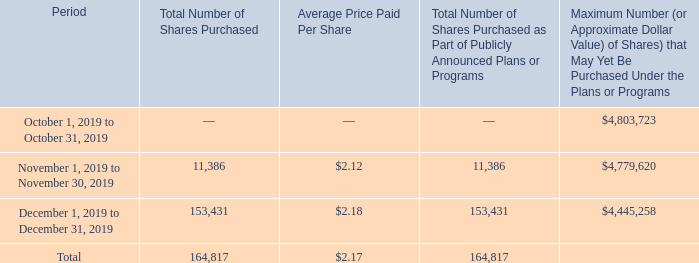Stock Repurchases. On August 22, 2011, we established a share repurchase program ("Share Repurchase Program"). On June 11, 2019, our Board of Directors authorized an extension and increase of the Share Repurchase Program to repurchase up to $5,000,000 of shares of our common stock over the subsequent 24 month period (for a total authorization of approximately $22,000,000 since inception of the program in August 2011). The common stock may be repurchased from time to time in open market transactions or privately negotiated transactions in our discretion. The timing and amount of the shares repurchased is determined by management based on its evaluation of market conditions and other factors. The Share Repurchase Program may be increased, suspended or discontinued at any time.
During the months of October, November and December 2019, we repurchased common stock pursuant to our Share Repurchase Program as indicated below:
During the year ended December 31, 2019, we repurchased an aggregate of 335,372 shares of our common stock pursuant to our Share Repurchase Program at a cost of approximately $764,606 (exclusive of commissions) or an average price per share of $2.28.
During the year ended December 31, 2019, we repurchased an aggregate of 335,372 shares of our common stock pursuant to our Share Repurchase Program at a cost of approximately $764,606 (exclusive of commissions) or an average price per share of $2.28.
Since inception of our Share Repurchase Program (August 2011) to December 31, 2019, we repurchased an aggregate of 8,489,770 shares of our common stock at a cost of approximately $15,906,846 (exclusive of commissions) or an average per share price of $1.87.
How many shares did the company repurchase during the year ended December 31, 2019? 335,372 shares. How many shares did the company repurchase since the inception of the Share Repurchase Program? 8,489,770 shares. How much did it cost to repurchase shares under the Share Repurchase Program? Cost of approximately $15,906,846. How many shares did the company purchase prior to October 1, 2019 for 2019? 335,372 - 164,817
Answer: 170555. What % of total shares purchased during year ended December 31, 2019 were shares purchased during October 1, 2019 to December 31, 2019?
Answer scale should be: percent. 164,817/335,372
Answer: 49.14. What % of total shares purchased since the inception of the Share Repurchase Program were shares purchased during year ended December 31, 2019?
Answer scale should be: percent. 335,372/8,489,770
Answer: 3.95. 